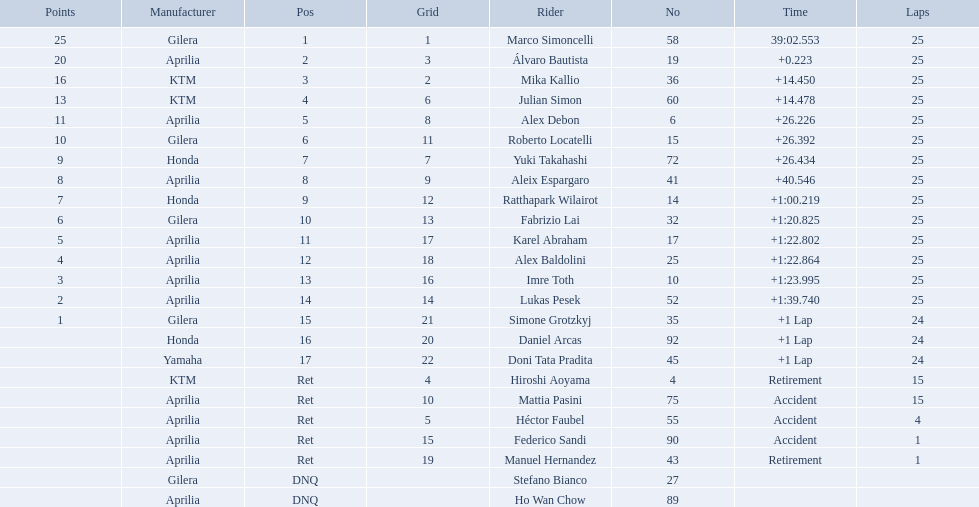What player number is marked #1 for the australian motorcycle grand prix? 58. Who is the rider that represents the #58 in the australian motorcycle grand prix? Marco Simoncelli. 